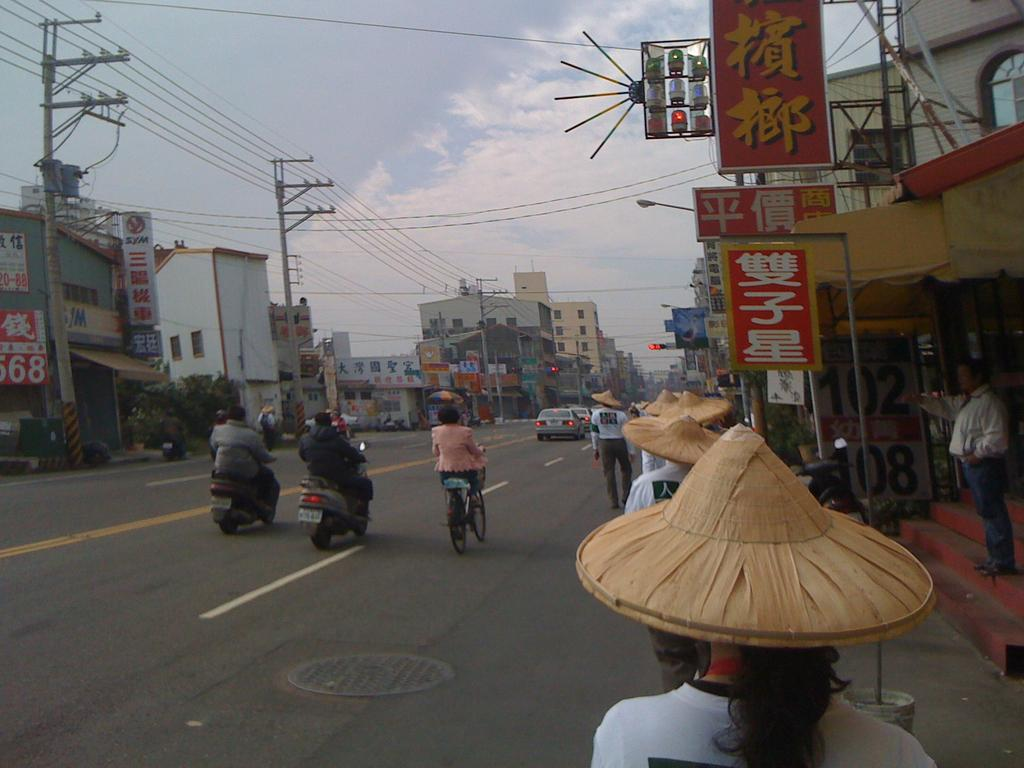<image>
Render a clear and concise summary of the photo. Three people on scooters are about to pass the SYM business on their left. 